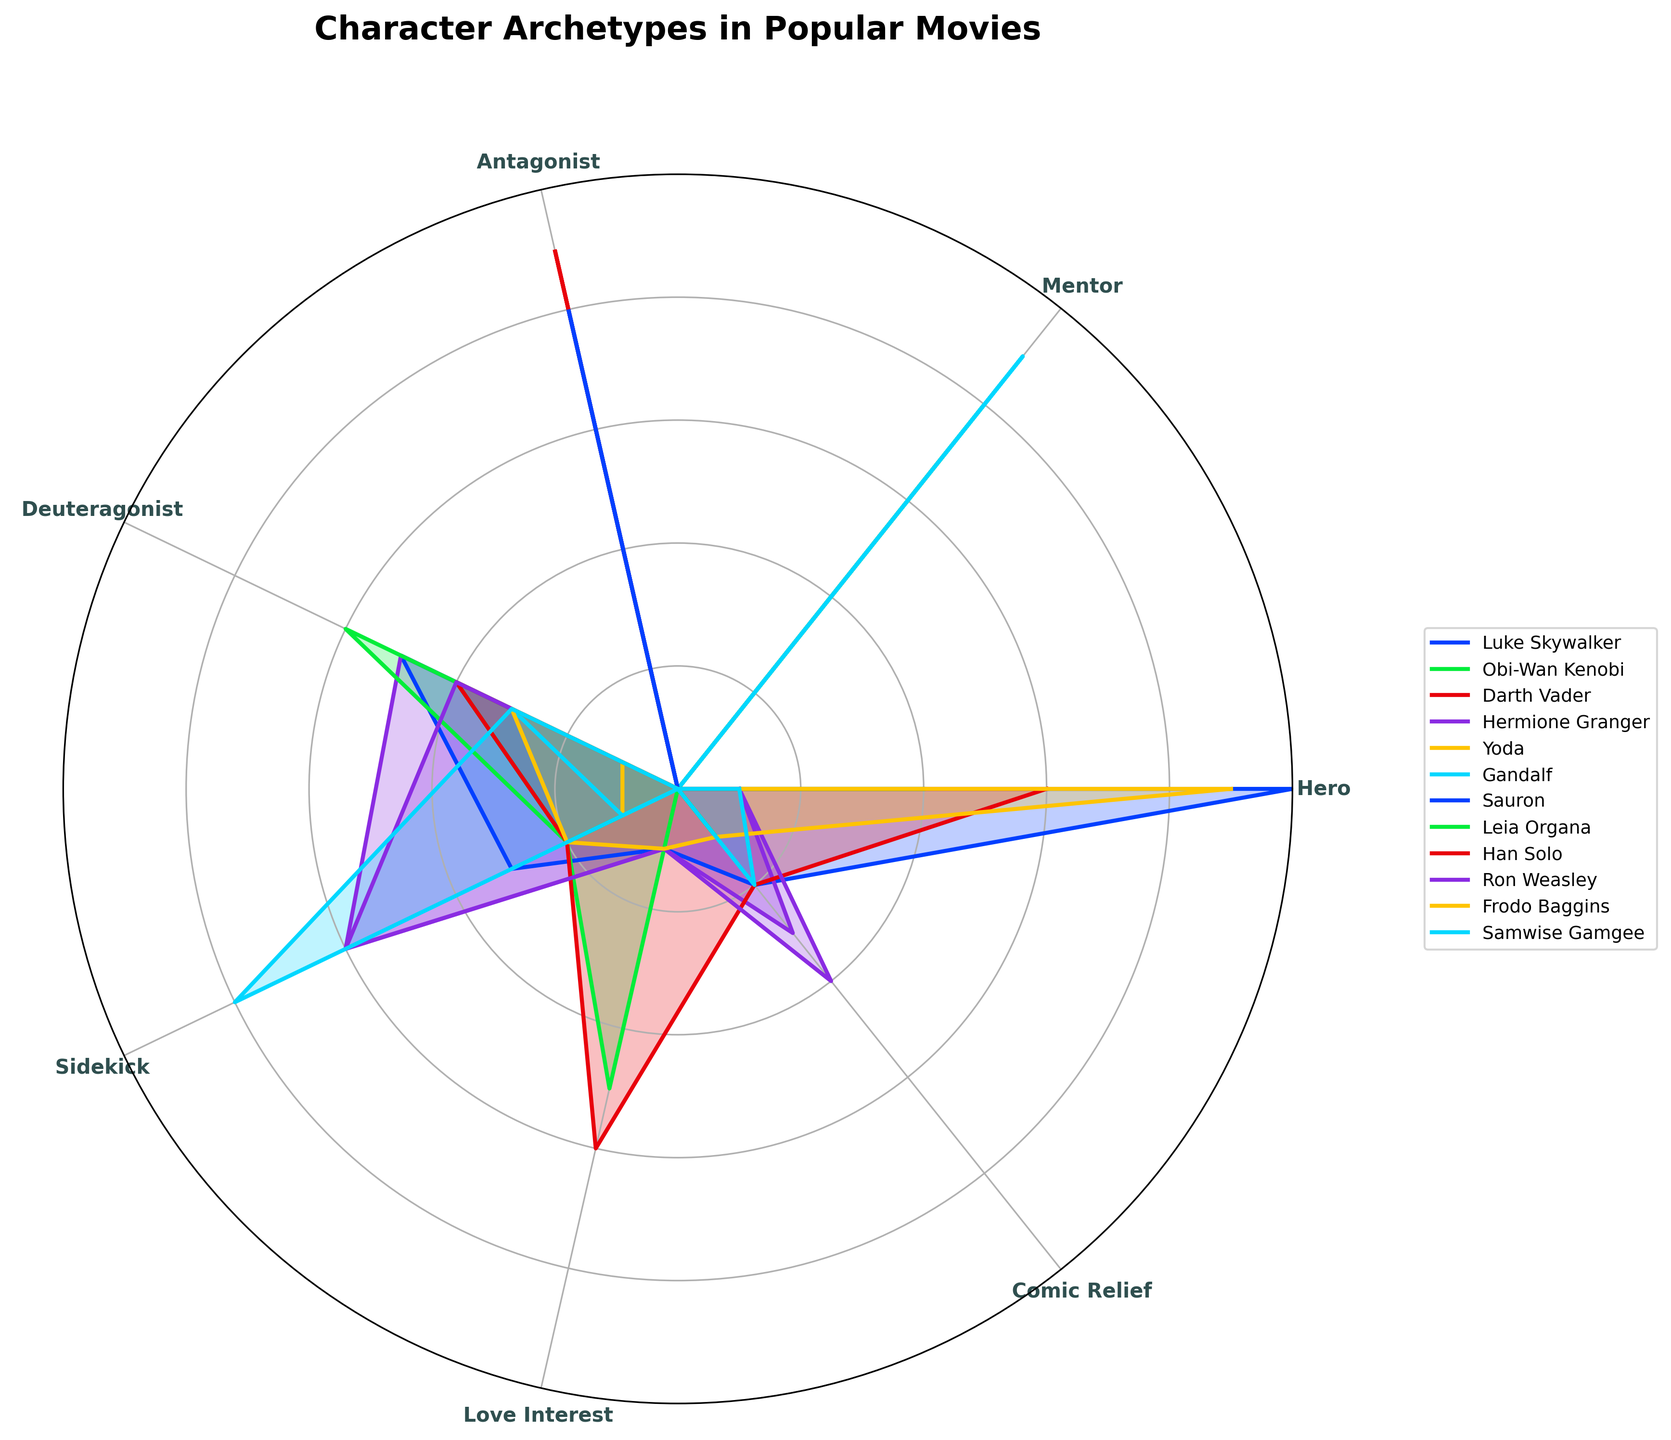What is the title of the plot? The title of the plot is generally placed at the top for easy identification. It states the main subject and context of the figure. The title in this plot is "Character Archetypes in Popular Movies".
Answer: Character Archetypes in Popular Movies Which character is both a hero and a deuteragonist, with equal roles? To identify this, look for characters with equal values in the Hero and Deuteragonist categories. Frodo Baggins has 9 as Hero and 3 as Deuteragonist, and Han Solo has 6 as Hero and 4 as Deuteragonist. They are not equal in both categories. Thus, no such character exists.
Answer: No such character Who has the highest value in the Antagonist role? Compare the values in the Antagonist role for all characters. Both Darth Vader and Sauron have the highest value with a count of 9 and 8, respectively. The highest value is 9, corresponding to Darth Vader.
Answer: Darth Vader What is the sum of Luke Skywalker's roles in the Hero and Sidekick categories? Sum the values for Luke Skywalker in the Hero (10) and Sidekick (3) categories. Adding these values gives 10 + 3 = 13.
Answer: 13 Which character has the highest combined value for the Mentor and Comic Relief roles? Add the values for Mentor and Comic Relief roles for each character and find the highest sum. Obi-Wan Kenobi has 8 (Mentor) + 1 (Comic Relief) = 9, Yoda has 7 + 0 = 7, and Gandalf has 9 + 0 = 9. The others have lower sums. Obi-Wan Kenobi and Gandalf tie at 9.
Answer: Obi-Wan Kenobi, Gandalf Which narrative role is most frequent for Hermione Granger? Look at the values for Hermione Granger across all narrative roles. The highest value is for Sidekick, with a count of 6.
Answer: Sidekick Who has the highest values of Hero and Mentor combined? Sum the Hero and Mentor values for all characters. Luke Skywalker has 10 (Hero) + 0 (Mentor) = 10, Obi-Wan Kenobi has 8, Gandalf has 9. Luke Skywalker has the highest at 10 despite having 0 in Mentor.
Answer: Luke Skywalker Which narrative role has the lowest visual representation in the plot? Identify the narrative role across all characters with the lowest values in sum. Love Interest and Comic Relief have lower representations, but Comic Relief appears least overall.
Answer: Comic Relief 